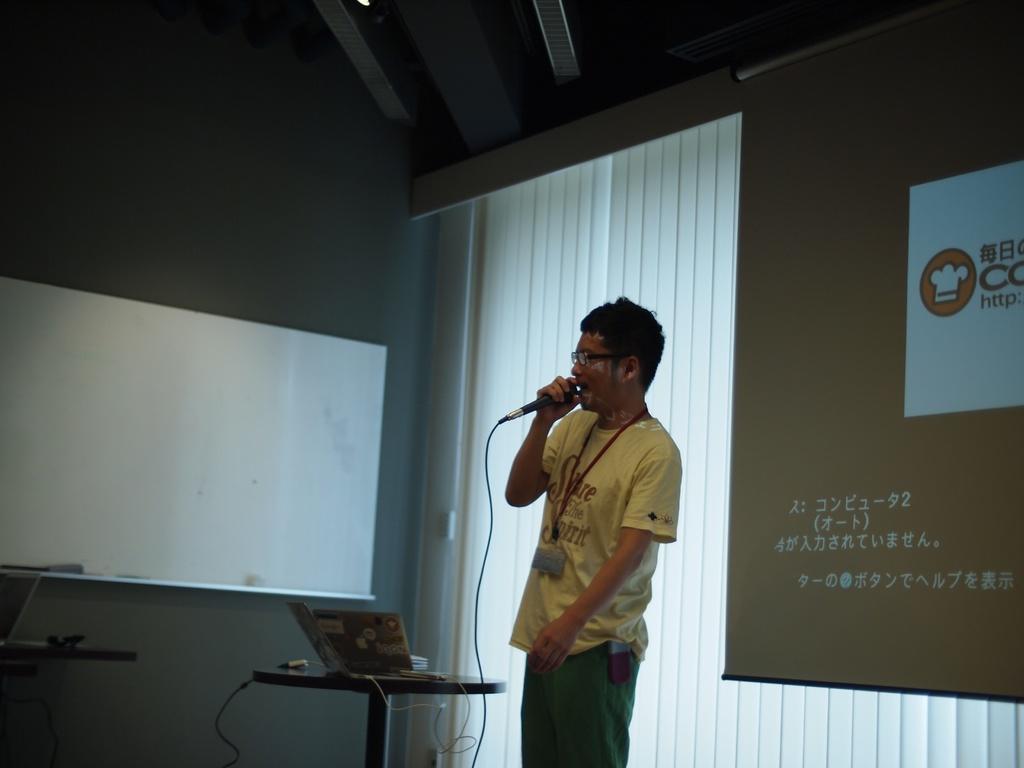How would you summarize this image in a sentence or two? In this image we can see a person wearing yellow color T-shirt green color pant also wearing Id card holding microphone in his hands singing and in the background of the image there are some white color curtains, projector screens laptop on the table. 